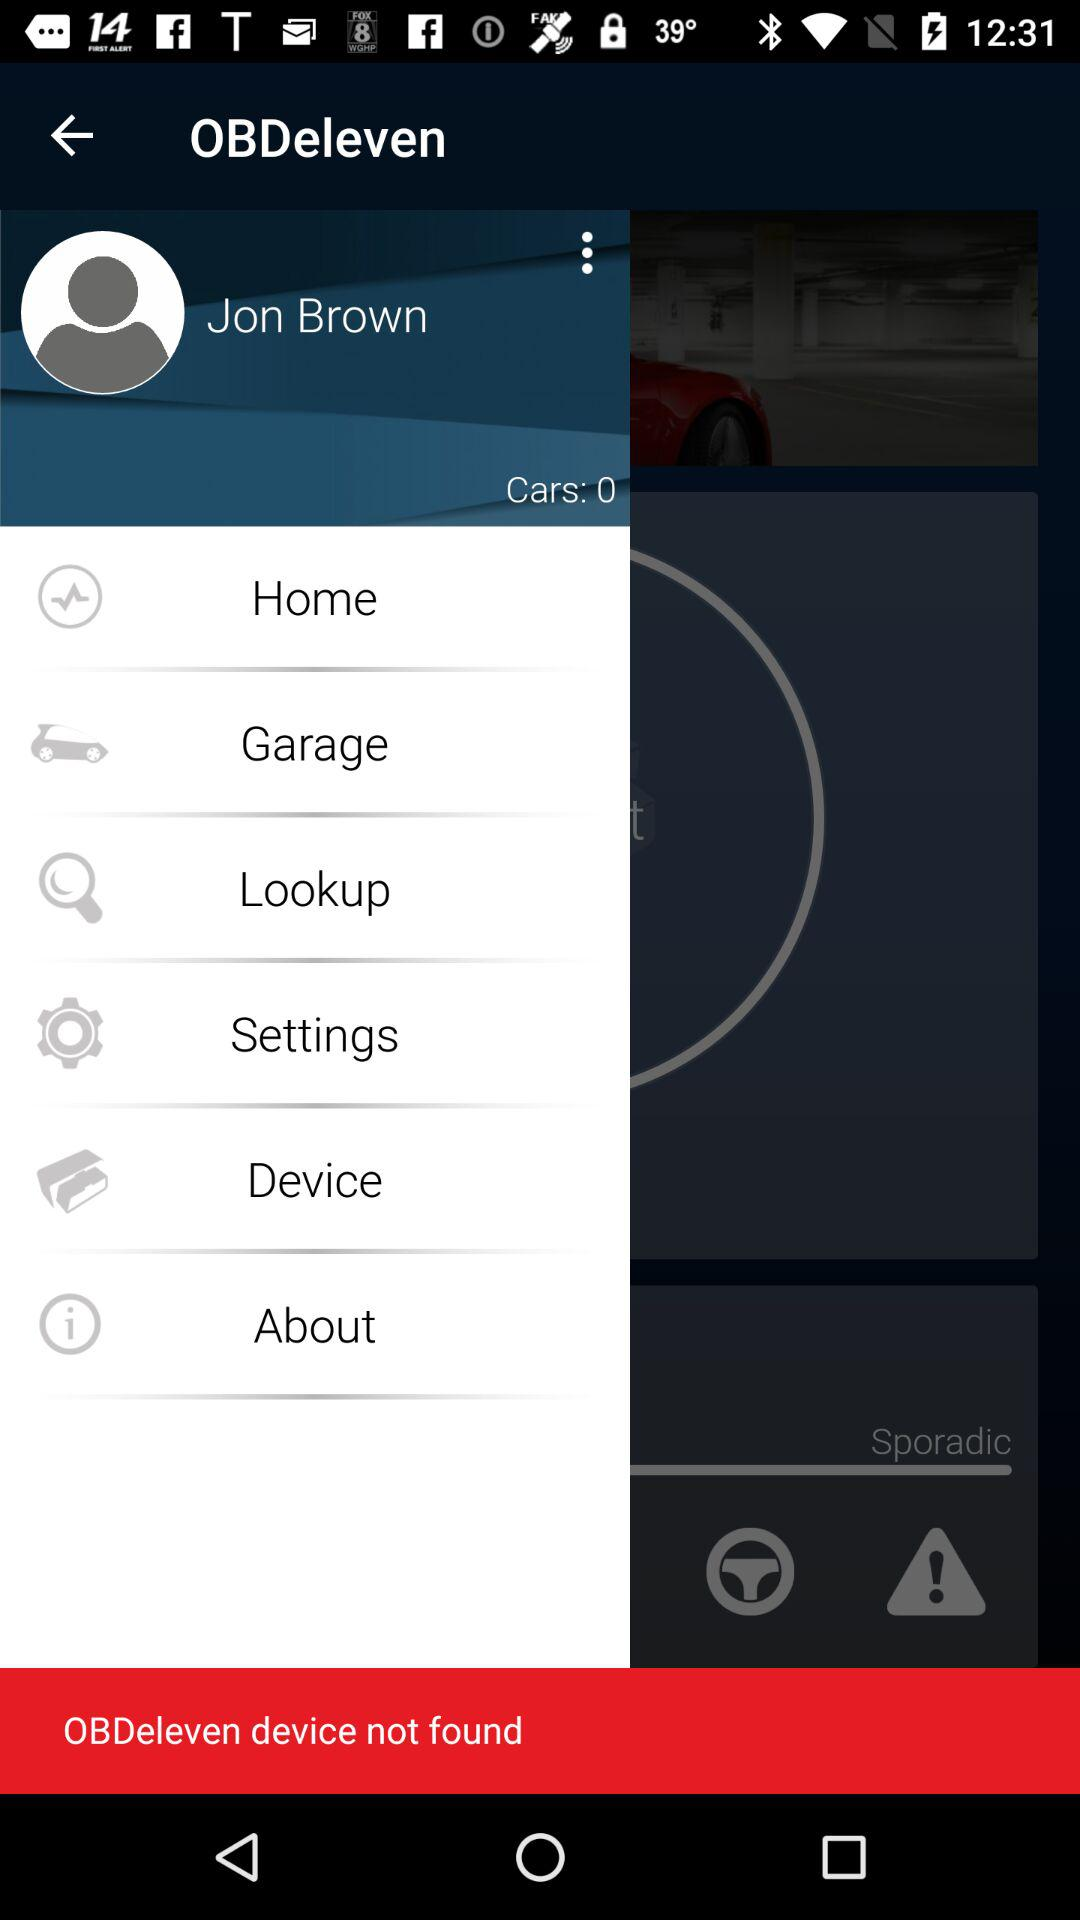What is the number of cars? The number of cars is 0. 